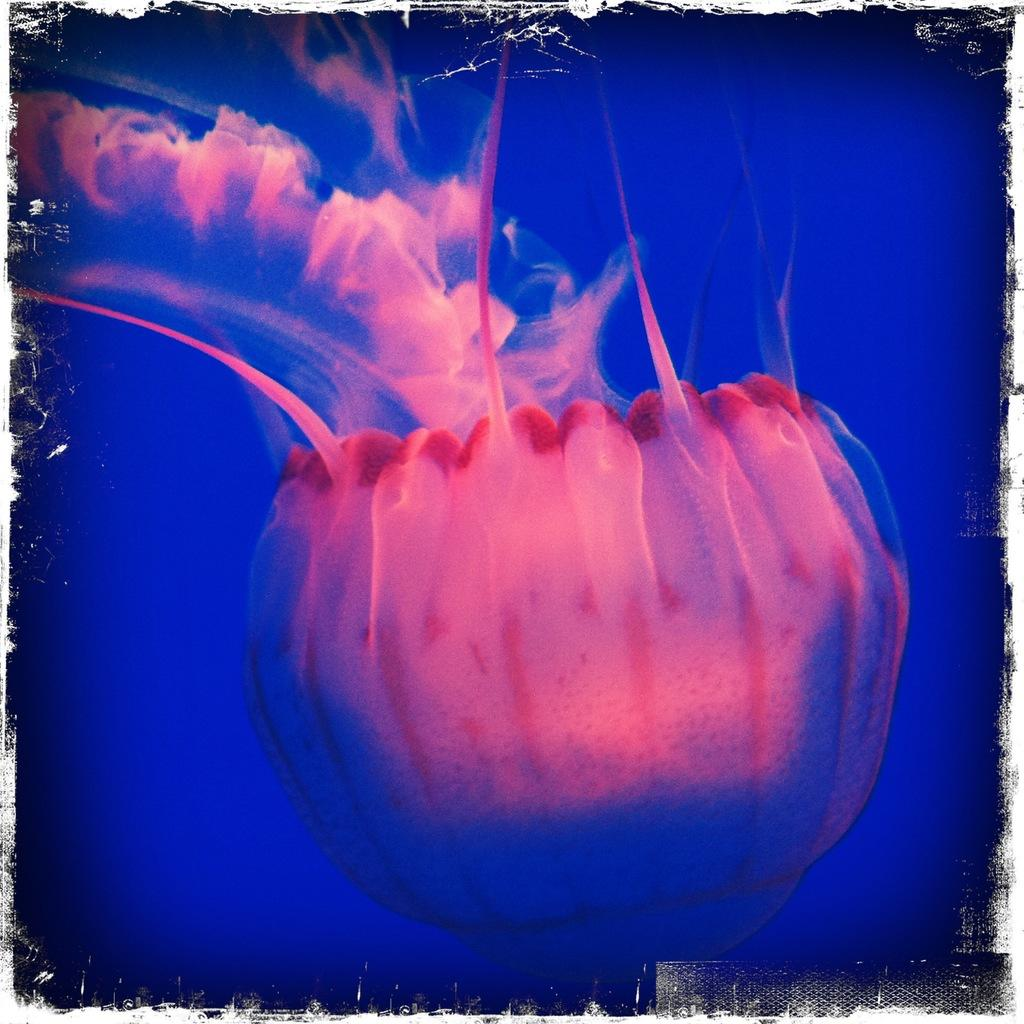What color is the background of the image? The background of the image is blue. What is the main subject of the image? There is a jellyfish in the image. What type of appliance can be seen in the image? There is no appliance present in the image; it features a jellyfish in a blue background. What instrument is the jellyfish playing in the image? There is no instrument or drum present in the image; it features a jellyfish in a blue background. 